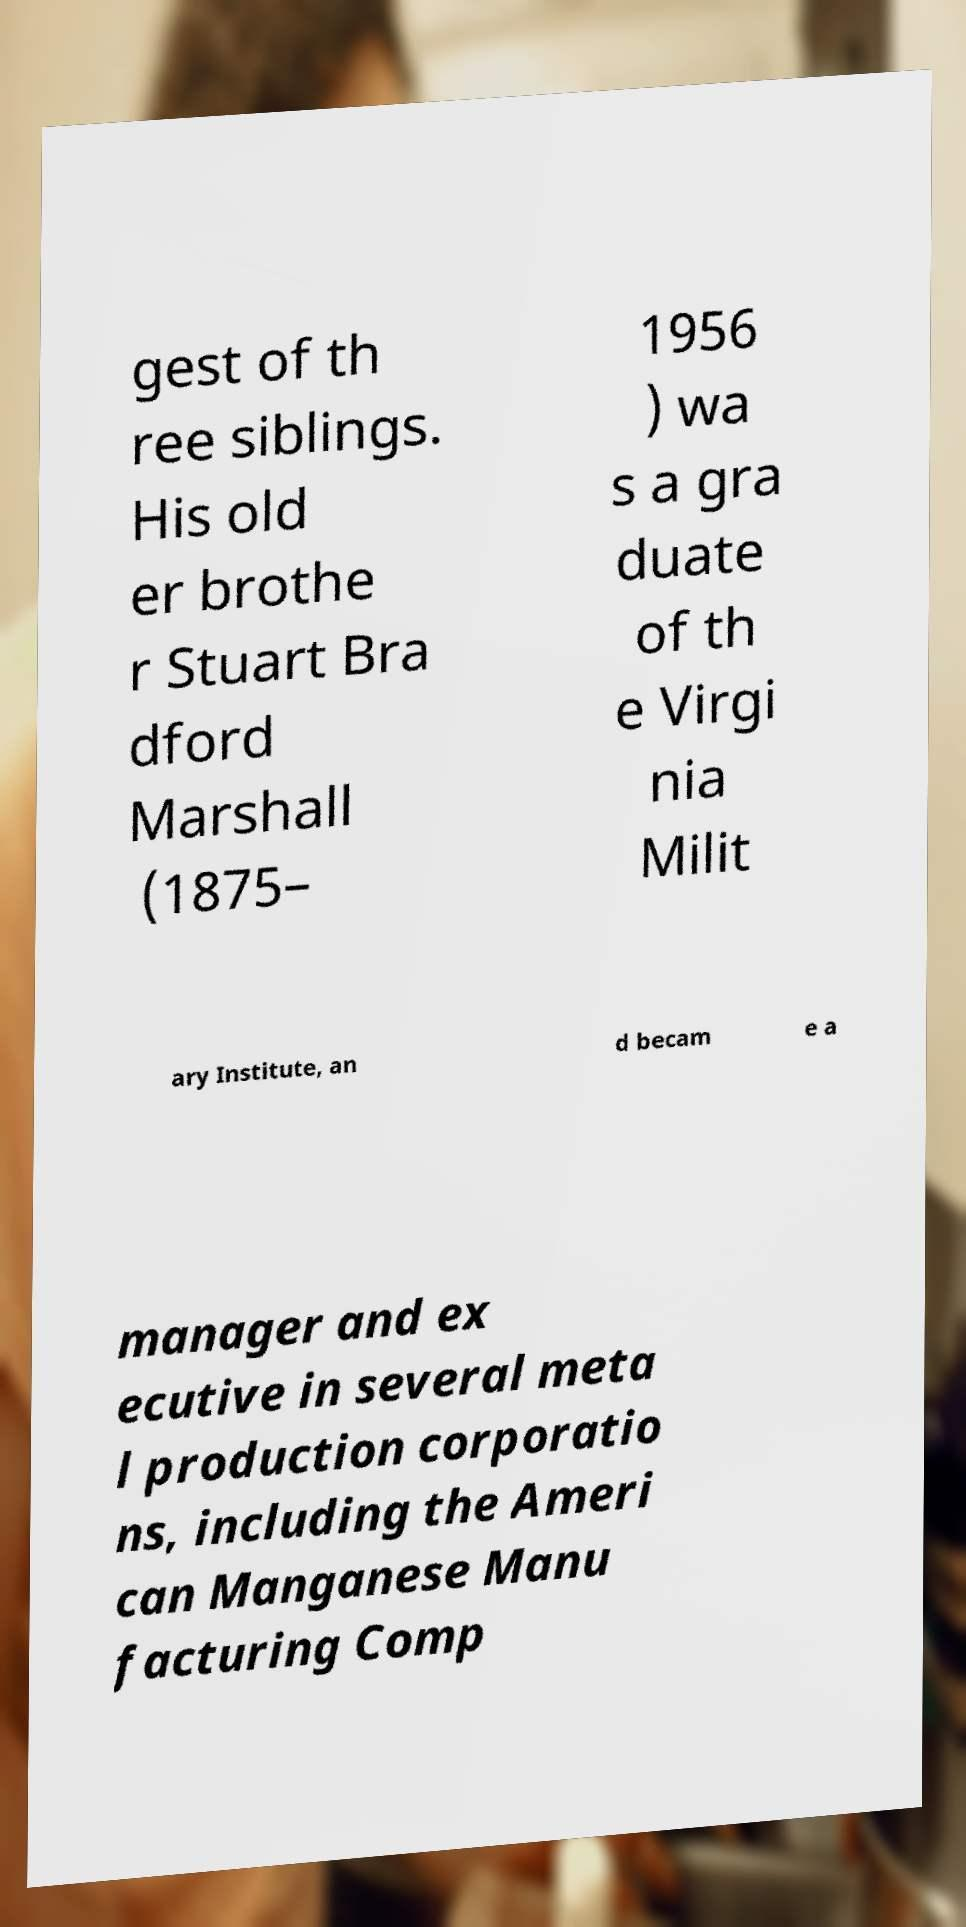Could you assist in decoding the text presented in this image and type it out clearly? gest of th ree siblings. His old er brothe r Stuart Bra dford Marshall (1875– 1956 ) wa s a gra duate of th e Virgi nia Milit ary Institute, an d becam e a manager and ex ecutive in several meta l production corporatio ns, including the Ameri can Manganese Manu facturing Comp 